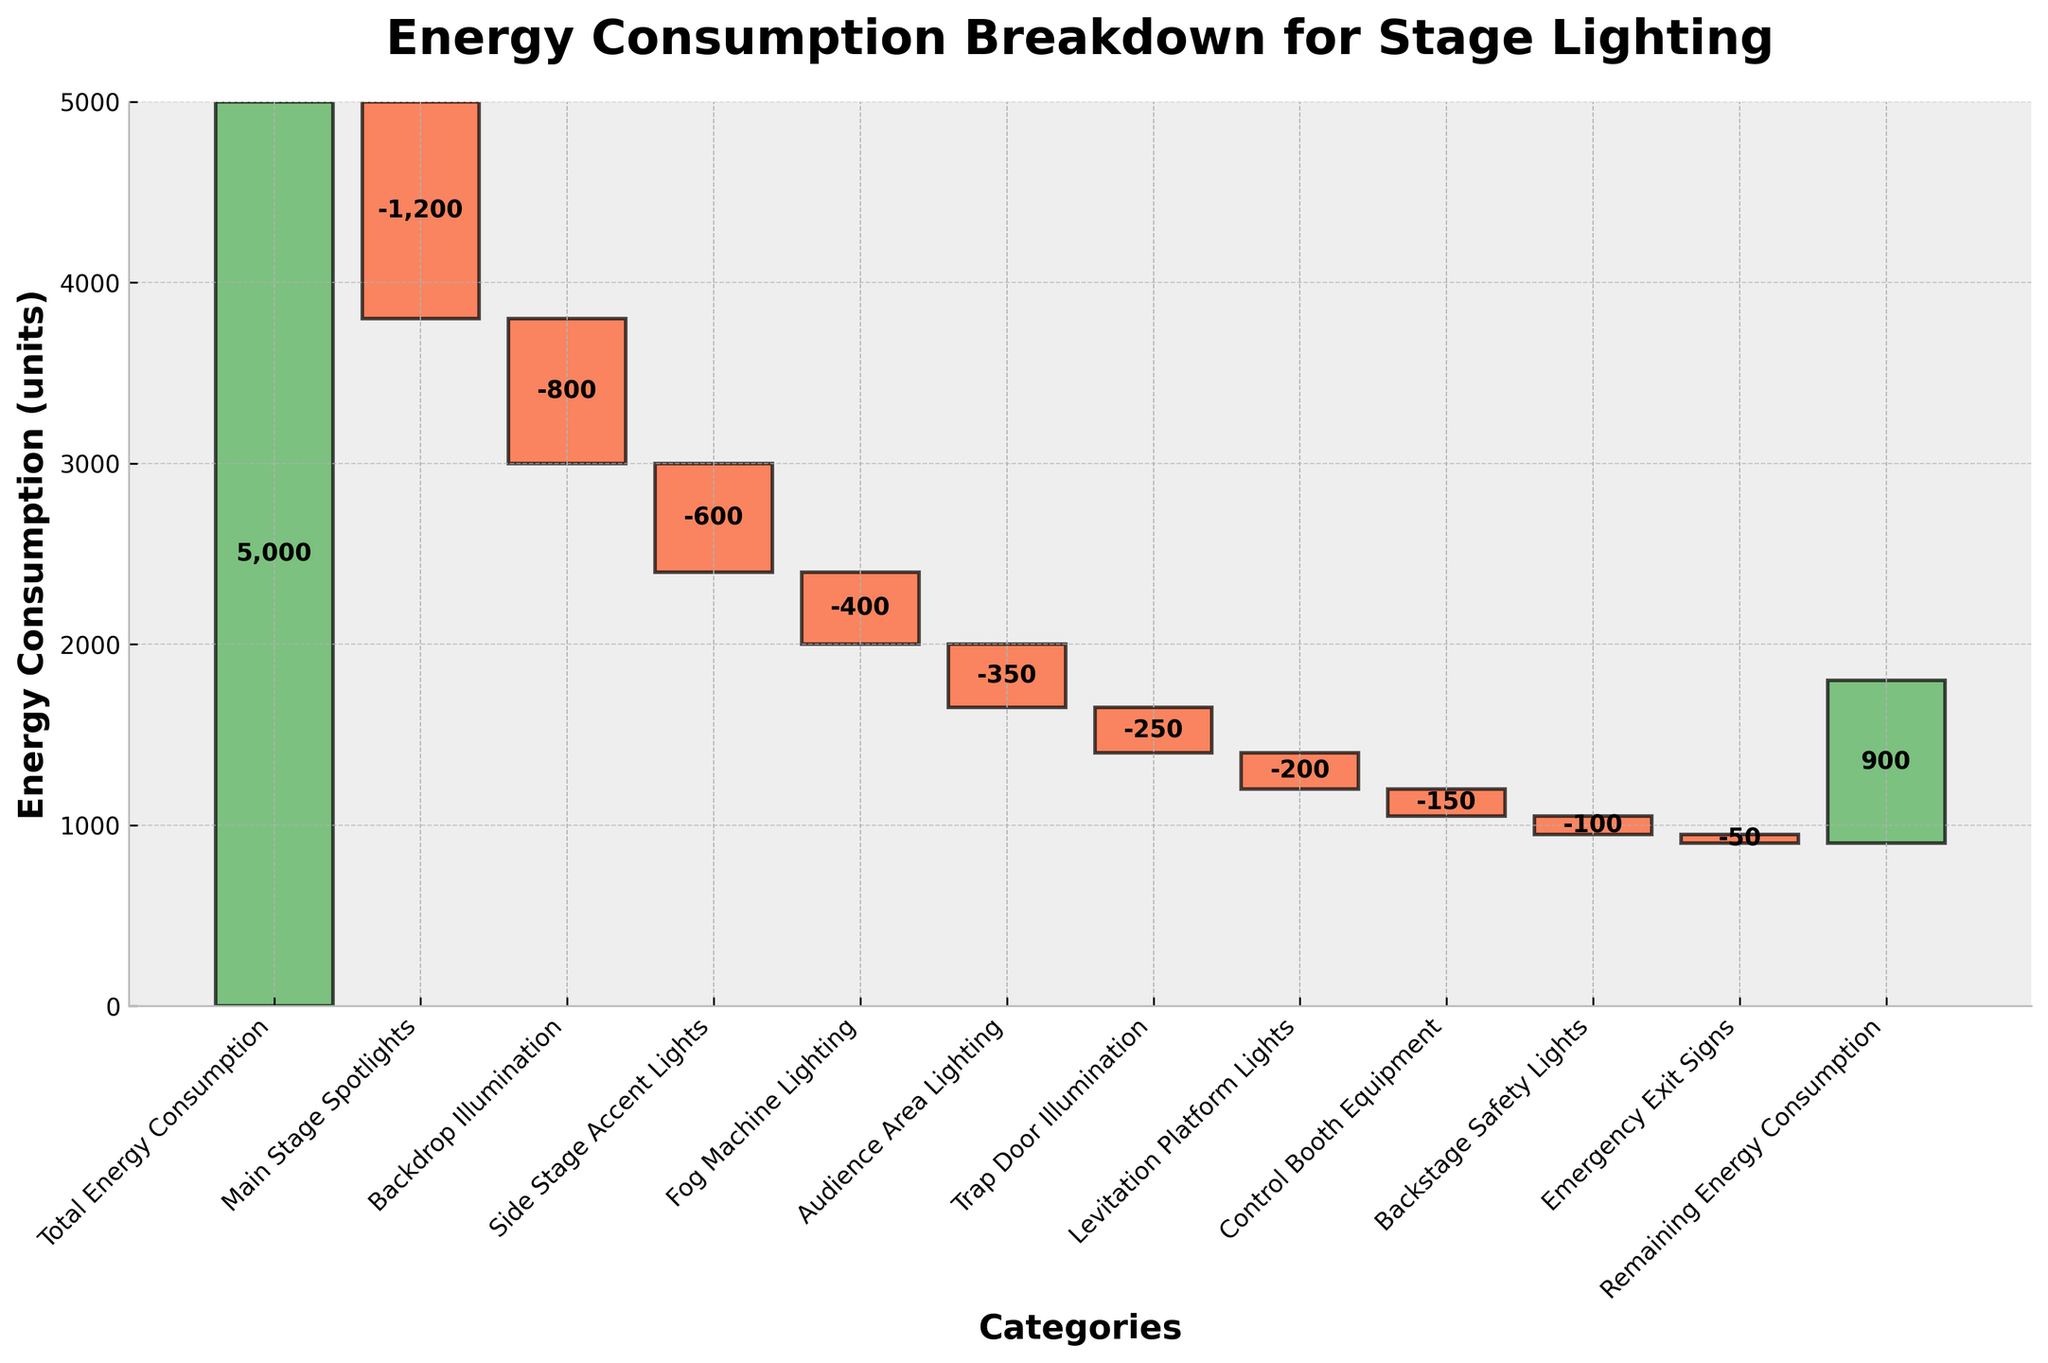How many categories of energy consumption are listed in the chart? Count the total distinct categories listed on the x-axis.
Answer: 11 What is the total remaining energy consumption after all specific stage lighting elements have been accounted for? Look at the value for "Remaining Energy Consumption" at the end of the chart.
Answer: 900 Which category has the smallest energy consumption? Identify the category at the top of the chart, indicating the smallest value.
Answer: Emergency Exit Signs How much energy is consumed by the Main Stage Spotlights and the Backdrop Illumination combined? Sum the values of Main Stage Spotlights (-1200) and Backdrop Illumination (-800).
Answer: -2000 What is the difference in energy consumption between the Side Stage Accent Lights and Levitation Platform Lights? Subtract the value of Levitation Platform Lights (-200) from the value of Side Stage Accent Lights (-600).
Answer: -400 Which category has the highest amount of energy consumption reduction? Identify the category with the largest negative value in the chart.
Answer: Main Stage Spotlights Compare the energy consumption of Trap Door Illumination and Control Booth Equipment. Which consumes more energy? Compare the values of Trap Door Illumination (-250) and Control Booth Equipment (-150).
Answer: Trap Door Illumination Considering only the illumination categories (Main Stage Spotlights, Backdrop Illumination, Side Stage Accent Lights, Fog Machine Lighting, Audience Area Lighting, Trap Door Illumination, Levitation Platform Lights), what is their total energy consumption? Sum the values of the mentioned categories: (-1200) + (-800) + (-600) + (-400) + (-350) + (-250) + (-200).
Answer: -3800 By how much does the Control Booth Equipment influence the total energy consumption compared to the Audience Area Lighting? Subtract the value of Control Booth Equipment (-150) from the value of Audience Area Lighting (-350).
Answer: 200 